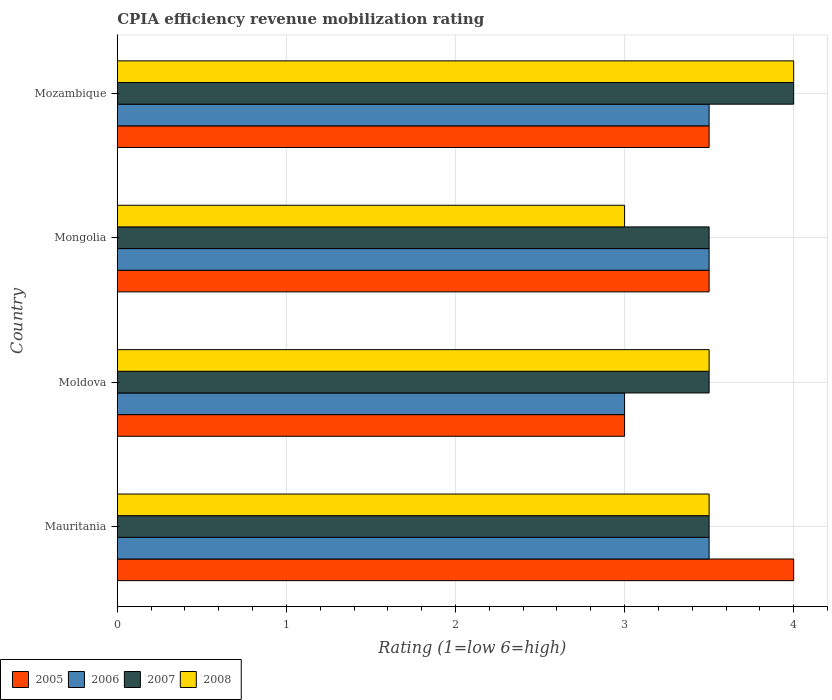How many groups of bars are there?
Make the answer very short. 4. Are the number of bars on each tick of the Y-axis equal?
Your answer should be very brief. Yes. How many bars are there on the 4th tick from the top?
Your answer should be very brief. 4. What is the label of the 3rd group of bars from the top?
Offer a very short reply. Moldova. What is the CPIA rating in 2007 in Mauritania?
Provide a short and direct response. 3.5. Across all countries, what is the maximum CPIA rating in 2008?
Make the answer very short. 4. Across all countries, what is the minimum CPIA rating in 2005?
Keep it short and to the point. 3. In which country was the CPIA rating in 2008 maximum?
Provide a short and direct response. Mozambique. In which country was the CPIA rating in 2005 minimum?
Your answer should be compact. Moldova. What is the difference between the CPIA rating in 2005 in Moldova and that in Mongolia?
Give a very brief answer. -0.5. What is the difference between the CPIA rating in 2006 in Moldova and the CPIA rating in 2007 in Mauritania?
Offer a very short reply. -0.5. What is the average CPIA rating in 2006 per country?
Give a very brief answer. 3.38. What is the difference between the CPIA rating in 2006 and CPIA rating in 2005 in Mauritania?
Make the answer very short. -0.5. Is the CPIA rating in 2008 in Mauritania less than that in Moldova?
Ensure brevity in your answer.  No. Is the difference between the CPIA rating in 2006 in Mauritania and Mongolia greater than the difference between the CPIA rating in 2005 in Mauritania and Mongolia?
Ensure brevity in your answer.  No. What is the difference between the highest and the lowest CPIA rating in 2005?
Provide a succinct answer. 1. What does the 4th bar from the top in Moldova represents?
Offer a terse response. 2005. How many bars are there?
Your response must be concise. 16. Are the values on the major ticks of X-axis written in scientific E-notation?
Make the answer very short. No. Where does the legend appear in the graph?
Your answer should be very brief. Bottom left. What is the title of the graph?
Provide a short and direct response. CPIA efficiency revenue mobilization rating. Does "1969" appear as one of the legend labels in the graph?
Give a very brief answer. No. What is the Rating (1=low 6=high) in 2005 in Mauritania?
Your answer should be very brief. 4. What is the Rating (1=low 6=high) of 2006 in Mauritania?
Keep it short and to the point. 3.5. What is the Rating (1=low 6=high) of 2007 in Mauritania?
Give a very brief answer. 3.5. What is the Rating (1=low 6=high) in 2008 in Mauritania?
Provide a short and direct response. 3.5. What is the Rating (1=low 6=high) in 2006 in Moldova?
Your answer should be compact. 3. What is the Rating (1=low 6=high) of 2005 in Mongolia?
Provide a succinct answer. 3.5. What is the Rating (1=low 6=high) of 2006 in Mongolia?
Your response must be concise. 3.5. Across all countries, what is the maximum Rating (1=low 6=high) of 2008?
Provide a succinct answer. 4. Across all countries, what is the minimum Rating (1=low 6=high) in 2005?
Offer a very short reply. 3. Across all countries, what is the minimum Rating (1=low 6=high) in 2008?
Give a very brief answer. 3. What is the total Rating (1=low 6=high) in 2006 in the graph?
Your answer should be very brief. 13.5. What is the total Rating (1=low 6=high) of 2008 in the graph?
Make the answer very short. 14. What is the difference between the Rating (1=low 6=high) of 2005 in Mauritania and that in Moldova?
Make the answer very short. 1. What is the difference between the Rating (1=low 6=high) of 2008 in Mauritania and that in Moldova?
Your answer should be very brief. 0. What is the difference between the Rating (1=low 6=high) of 2005 in Mauritania and that in Mozambique?
Provide a succinct answer. 0.5. What is the difference between the Rating (1=low 6=high) of 2006 in Mauritania and that in Mozambique?
Keep it short and to the point. 0. What is the difference between the Rating (1=low 6=high) of 2008 in Mauritania and that in Mozambique?
Keep it short and to the point. -0.5. What is the difference between the Rating (1=low 6=high) in 2005 in Moldova and that in Mongolia?
Offer a very short reply. -0.5. What is the difference between the Rating (1=low 6=high) of 2006 in Moldova and that in Mongolia?
Provide a short and direct response. -0.5. What is the difference between the Rating (1=low 6=high) in 2007 in Moldova and that in Mongolia?
Your answer should be compact. 0. What is the difference between the Rating (1=low 6=high) in 2007 in Moldova and that in Mozambique?
Provide a short and direct response. -0.5. What is the difference between the Rating (1=low 6=high) of 2008 in Moldova and that in Mozambique?
Offer a very short reply. -0.5. What is the difference between the Rating (1=low 6=high) in 2007 in Mongolia and that in Mozambique?
Your answer should be very brief. -0.5. What is the difference between the Rating (1=low 6=high) of 2008 in Mongolia and that in Mozambique?
Offer a terse response. -1. What is the difference between the Rating (1=low 6=high) in 2005 in Mauritania and the Rating (1=low 6=high) in 2008 in Moldova?
Offer a terse response. 0.5. What is the difference between the Rating (1=low 6=high) in 2006 in Mauritania and the Rating (1=low 6=high) in 2008 in Moldova?
Provide a succinct answer. 0. What is the difference between the Rating (1=low 6=high) in 2007 in Mauritania and the Rating (1=low 6=high) in 2008 in Moldova?
Ensure brevity in your answer.  0. What is the difference between the Rating (1=low 6=high) in 2005 in Mauritania and the Rating (1=low 6=high) in 2006 in Mongolia?
Your answer should be compact. 0.5. What is the difference between the Rating (1=low 6=high) of 2005 in Mauritania and the Rating (1=low 6=high) of 2007 in Mongolia?
Provide a succinct answer. 0.5. What is the difference between the Rating (1=low 6=high) of 2006 in Mauritania and the Rating (1=low 6=high) of 2008 in Mongolia?
Your answer should be compact. 0.5. What is the difference between the Rating (1=low 6=high) of 2007 in Mauritania and the Rating (1=low 6=high) of 2008 in Mongolia?
Provide a succinct answer. 0.5. What is the difference between the Rating (1=low 6=high) of 2005 in Mauritania and the Rating (1=low 6=high) of 2006 in Mozambique?
Provide a short and direct response. 0.5. What is the difference between the Rating (1=low 6=high) of 2005 in Mauritania and the Rating (1=low 6=high) of 2008 in Mozambique?
Offer a very short reply. 0. What is the difference between the Rating (1=low 6=high) in 2006 in Mauritania and the Rating (1=low 6=high) in 2008 in Mozambique?
Offer a terse response. -0.5. What is the difference between the Rating (1=low 6=high) of 2007 in Mauritania and the Rating (1=low 6=high) of 2008 in Mozambique?
Give a very brief answer. -0.5. What is the difference between the Rating (1=low 6=high) of 2006 in Moldova and the Rating (1=low 6=high) of 2007 in Mongolia?
Your answer should be very brief. -0.5. What is the difference between the Rating (1=low 6=high) of 2006 in Moldova and the Rating (1=low 6=high) of 2008 in Mongolia?
Give a very brief answer. 0. What is the difference between the Rating (1=low 6=high) in 2005 in Moldova and the Rating (1=low 6=high) in 2006 in Mozambique?
Ensure brevity in your answer.  -0.5. What is the difference between the Rating (1=low 6=high) of 2005 in Moldova and the Rating (1=low 6=high) of 2007 in Mozambique?
Offer a terse response. -1. What is the difference between the Rating (1=low 6=high) in 2006 in Moldova and the Rating (1=low 6=high) in 2007 in Mozambique?
Make the answer very short. -1. What is the difference between the Rating (1=low 6=high) in 2005 in Mongolia and the Rating (1=low 6=high) in 2008 in Mozambique?
Provide a succinct answer. -0.5. What is the average Rating (1=low 6=high) in 2005 per country?
Your answer should be very brief. 3.5. What is the average Rating (1=low 6=high) of 2006 per country?
Provide a succinct answer. 3.38. What is the average Rating (1=low 6=high) of 2007 per country?
Provide a short and direct response. 3.62. What is the average Rating (1=low 6=high) of 2008 per country?
Offer a very short reply. 3.5. What is the difference between the Rating (1=low 6=high) of 2005 and Rating (1=low 6=high) of 2007 in Mauritania?
Give a very brief answer. 0.5. What is the difference between the Rating (1=low 6=high) of 2007 and Rating (1=low 6=high) of 2008 in Mauritania?
Offer a very short reply. 0. What is the difference between the Rating (1=low 6=high) in 2005 and Rating (1=low 6=high) in 2006 in Moldova?
Ensure brevity in your answer.  0. What is the difference between the Rating (1=low 6=high) of 2005 and Rating (1=low 6=high) of 2007 in Moldova?
Offer a very short reply. -0.5. What is the difference between the Rating (1=low 6=high) of 2007 and Rating (1=low 6=high) of 2008 in Moldova?
Your answer should be compact. 0. What is the difference between the Rating (1=low 6=high) of 2005 and Rating (1=low 6=high) of 2008 in Mongolia?
Keep it short and to the point. 0.5. What is the difference between the Rating (1=low 6=high) in 2006 and Rating (1=low 6=high) in 2008 in Mongolia?
Provide a short and direct response. 0.5. What is the difference between the Rating (1=low 6=high) of 2007 and Rating (1=low 6=high) of 2008 in Mongolia?
Provide a succinct answer. 0.5. What is the difference between the Rating (1=low 6=high) in 2005 and Rating (1=low 6=high) in 2007 in Mozambique?
Your response must be concise. -0.5. What is the difference between the Rating (1=low 6=high) of 2006 and Rating (1=low 6=high) of 2007 in Mozambique?
Make the answer very short. -0.5. What is the ratio of the Rating (1=low 6=high) in 2005 in Mauritania to that in Moldova?
Your response must be concise. 1.33. What is the ratio of the Rating (1=low 6=high) of 2006 in Mauritania to that in Moldova?
Your response must be concise. 1.17. What is the ratio of the Rating (1=low 6=high) of 2007 in Mauritania to that in Moldova?
Your answer should be compact. 1. What is the ratio of the Rating (1=low 6=high) in 2006 in Mauritania to that in Mongolia?
Offer a very short reply. 1. What is the ratio of the Rating (1=low 6=high) of 2006 in Mauritania to that in Mozambique?
Offer a very short reply. 1. What is the ratio of the Rating (1=low 6=high) in 2007 in Mauritania to that in Mozambique?
Your answer should be compact. 0.88. What is the ratio of the Rating (1=low 6=high) in 2008 in Mauritania to that in Mozambique?
Your answer should be very brief. 0.88. What is the ratio of the Rating (1=low 6=high) in 2006 in Moldova to that in Mozambique?
Your answer should be very brief. 0.86. What is the ratio of the Rating (1=low 6=high) in 2007 in Moldova to that in Mozambique?
Make the answer very short. 0.88. What is the ratio of the Rating (1=low 6=high) in 2006 in Mongolia to that in Mozambique?
Give a very brief answer. 1. What is the ratio of the Rating (1=low 6=high) of 2007 in Mongolia to that in Mozambique?
Make the answer very short. 0.88. What is the difference between the highest and the second highest Rating (1=low 6=high) in 2005?
Provide a succinct answer. 0.5. What is the difference between the highest and the second highest Rating (1=low 6=high) in 2006?
Your answer should be compact. 0. What is the difference between the highest and the lowest Rating (1=low 6=high) in 2007?
Ensure brevity in your answer.  0.5. 